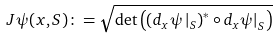<formula> <loc_0><loc_0><loc_500><loc_500>J \psi ( x , S ) \colon = \sqrt { \det \left ( \left ( d _ { x } \psi \left | _ { S } \right ) ^ { * } \circ d _ { x } \psi \right | _ { S } \right ) }</formula> 